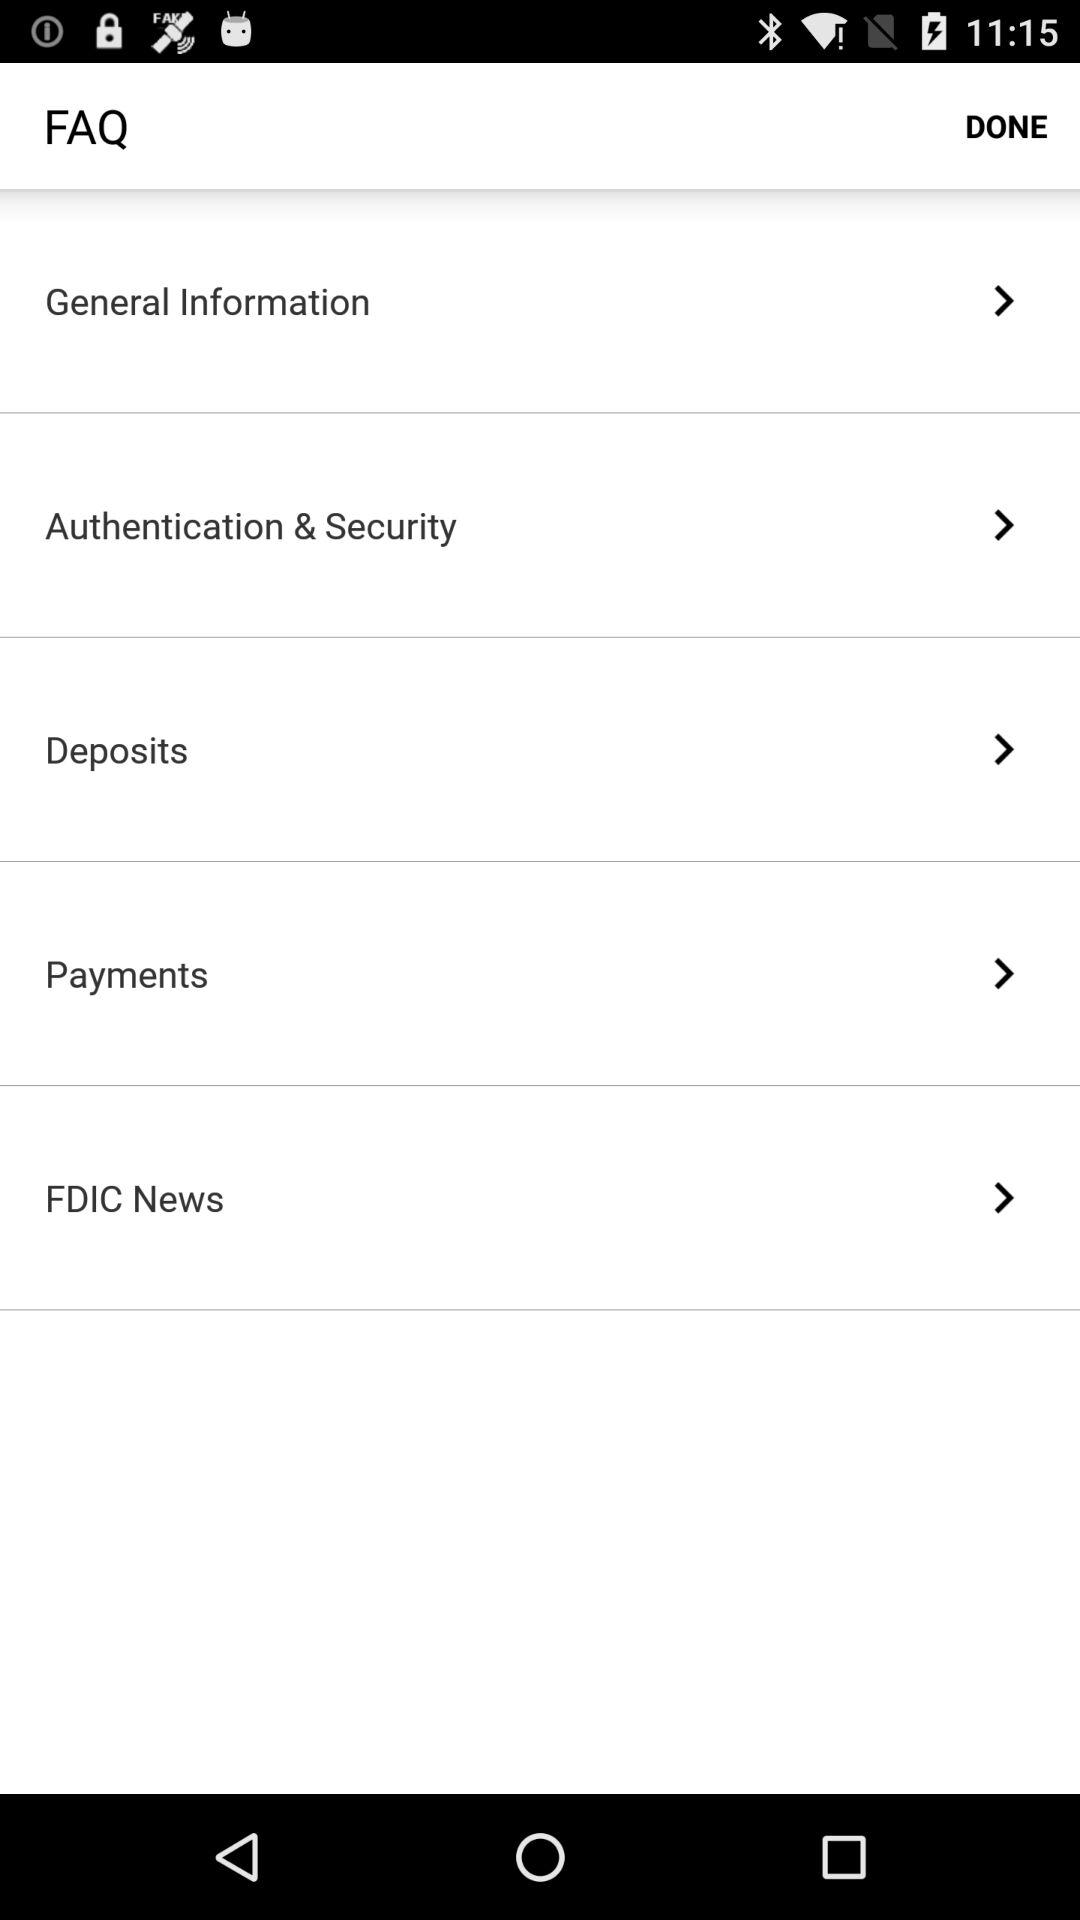How many FAQ items are there?
Answer the question using a single word or phrase. 5 